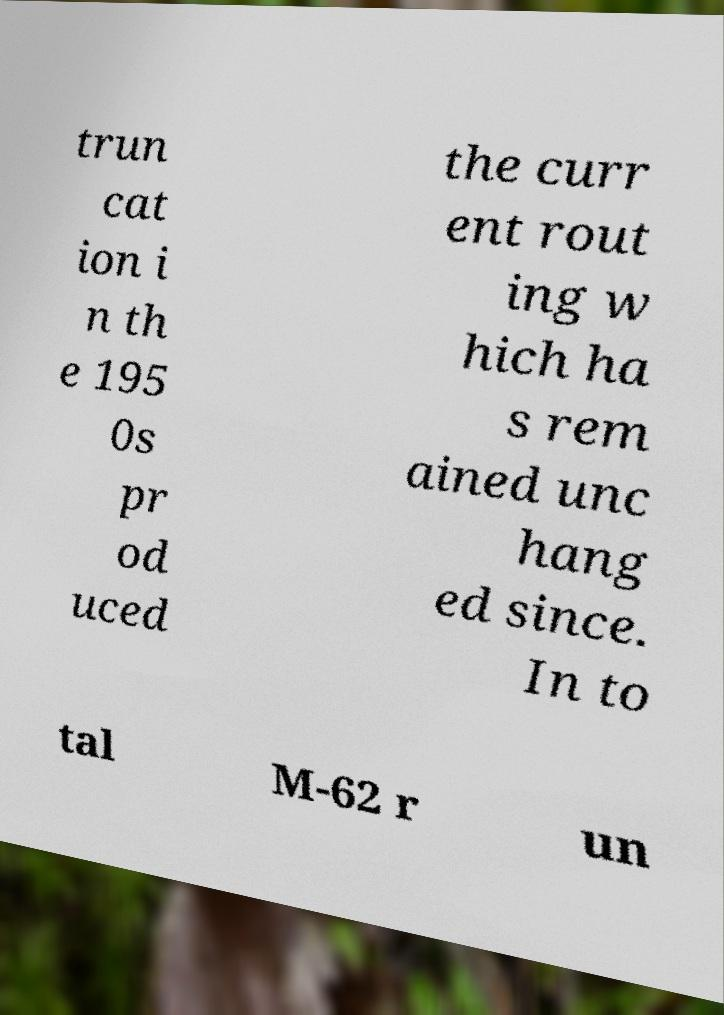Please read and relay the text visible in this image. What does it say? trun cat ion i n th e 195 0s pr od uced the curr ent rout ing w hich ha s rem ained unc hang ed since. In to tal M-62 r un 